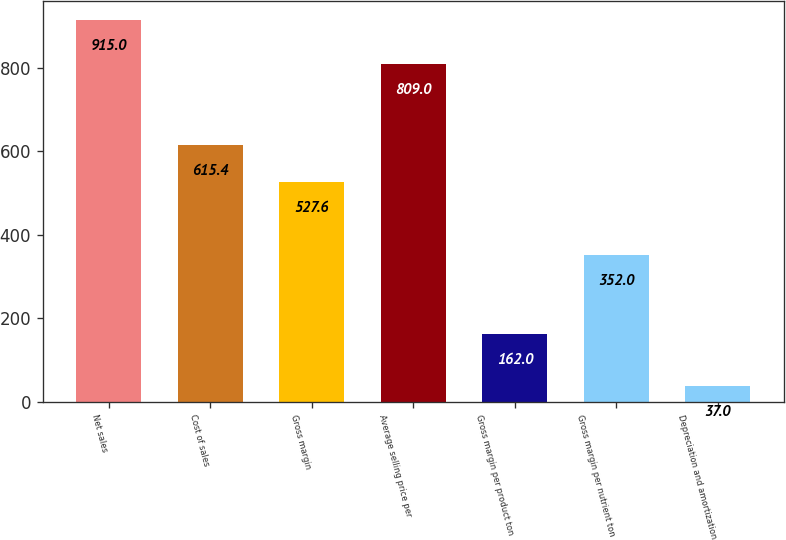<chart> <loc_0><loc_0><loc_500><loc_500><bar_chart><fcel>Net sales<fcel>Cost of sales<fcel>Gross margin<fcel>Average selling price per<fcel>Gross margin per product ton<fcel>Gross margin per nutrient ton<fcel>Depreciation and amortization<nl><fcel>915<fcel>615.4<fcel>527.6<fcel>809<fcel>162<fcel>352<fcel>37<nl></chart> 